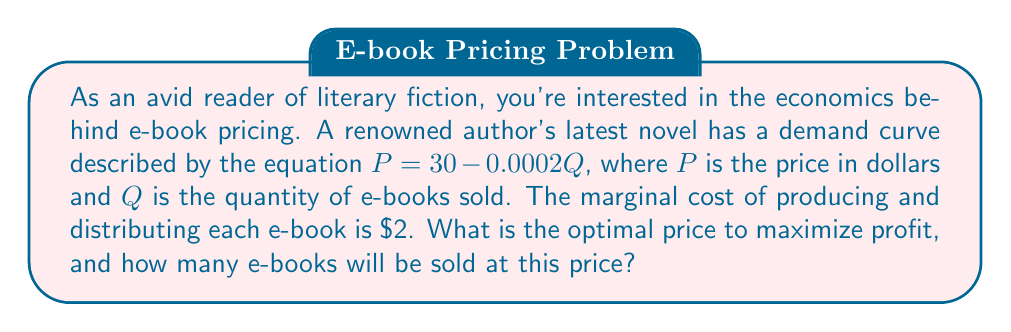What is the answer to this math problem? To solve this problem, we'll use the principles of microeconomics and profit maximization. Let's approach this step-by-step:

1) First, we need to find the revenue function. Revenue (R) is price times quantity:
   $R = PQ = (30 - 0.0002Q)Q = 30Q - 0.0002Q^2$

2) The cost function (C) is the marginal cost times quantity, plus any fixed costs. Here, we only have marginal costs:
   $C = 2Q$

3) Profit (π) is revenue minus cost:
   $π = R - C = (30Q - 0.0002Q^2) - 2Q = 28Q - 0.0002Q^2$

4) To maximize profit, we find where the derivative of the profit function equals zero:
   $\frac{dπ}{dQ} = 28 - 0.0004Q = 0$

5) Solving this equation:
   $28 - 0.0004Q = 0$
   $0.0004Q = 28$
   $Q = 70,000$

6) Now that we know the optimal quantity, we can find the optimal price by plugging this quantity back into our demand equation:
   $P = 30 - 0.0002(70,000) = 30 - 14 = 16$

7) To verify this is a maximum (not a minimum), we can check that the second derivative is negative:
   $\frac{d^2π}{dQ^2} = -0.0004 < 0$

Therefore, the optimal price is $16, and at this price, 70,000 e-books will be sold.
Answer: The optimal price to maximize profit is $16, and 70,000 e-books will be sold at this price. 